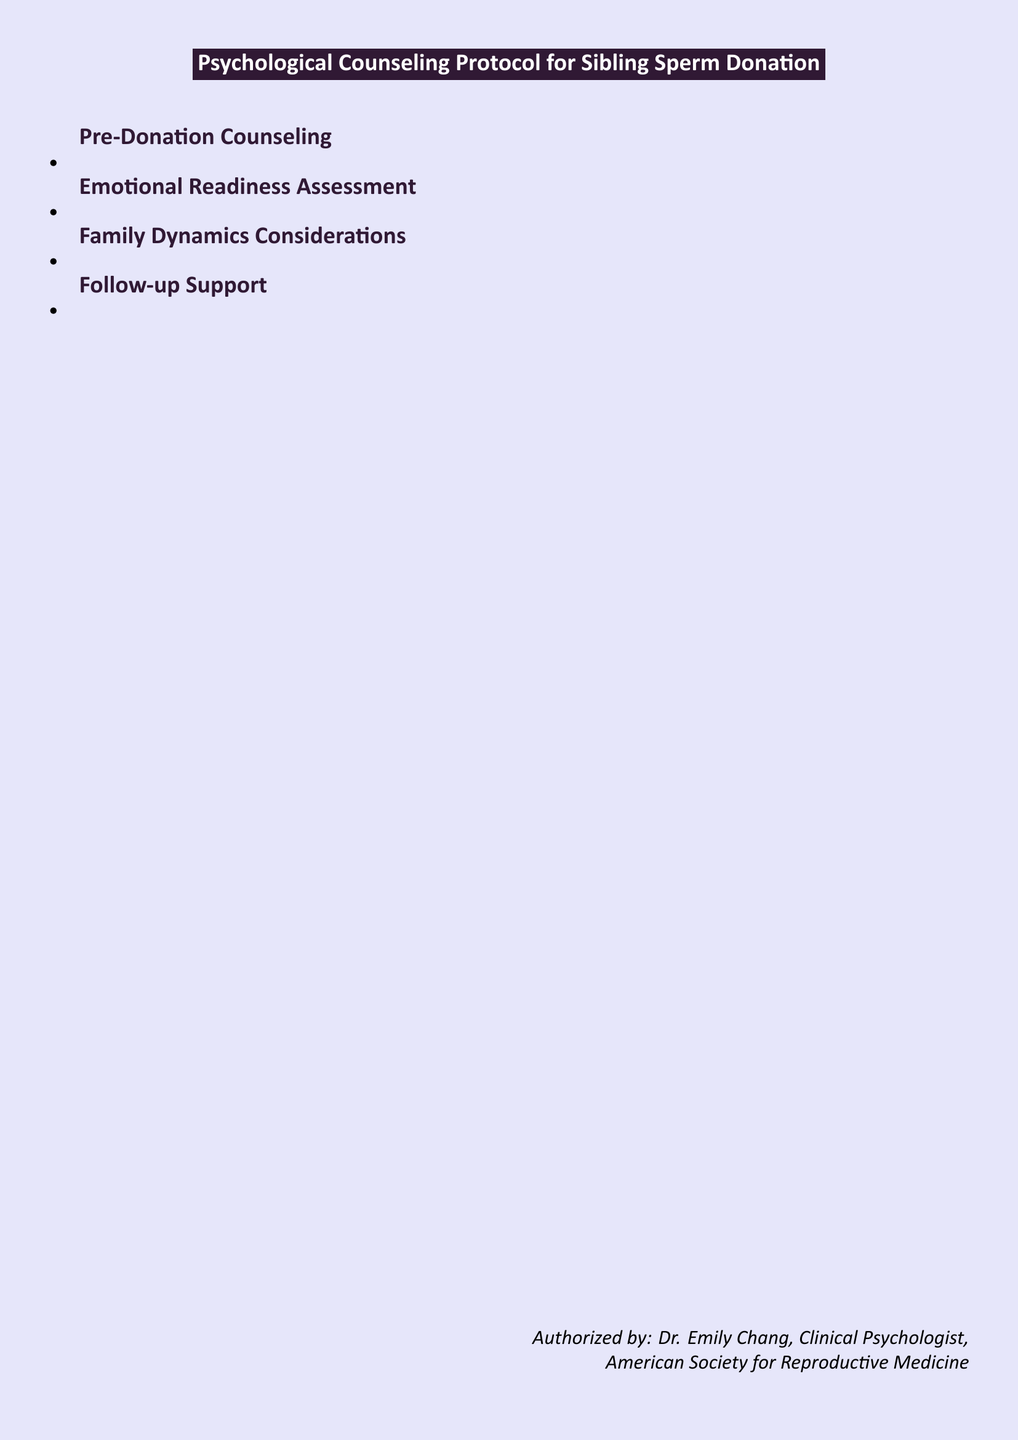What is the title of the document? The title of the document is stated prominently at the top, identifying its purpose and focus.
Answer: Psychological Counseling Protocol for Sibling Sperm Donation Who is the author of the document? The author is mentioned in the footer, identifying their role and affiliation with a relevant professional organization.
Answer: Dr. Emily Chang, Clinical Psychologist What is the first section of the document? The sections of the document are listed in order, with the first section detailing important pre-donation considerations.
Answer: Pre-Donation Counseling How many follow-up support check-ins are scheduled post-donation? The document outlines specific scheduled support sessions after the donation process.
Answer: Three What psychological test is recommended in the protocol? The document specifies a standardized psychological test recommended for use in the evaluation process.
Answer: MMPI-2 What is addressed in the Family Dynamics Considerations section? This section discusses important topics that impact relationships within the family structure after the donation.
Answer: Potential impact on existing family relationships What type of counseling session is suggested for both siblings? The document recommends a specific type of counseling session to facilitate effective communication.
Answer: Joint counseling session What should be explored regarding future relationships during counseling? The document highlights the importance of considering long-term implications on relationships after donation.
Answer: Future romantic relationships How often are annual counseling sessions proposed? The document suggests a specific frequency for annual counseling to monitor evolving family dynamics.
Answer: Annually 